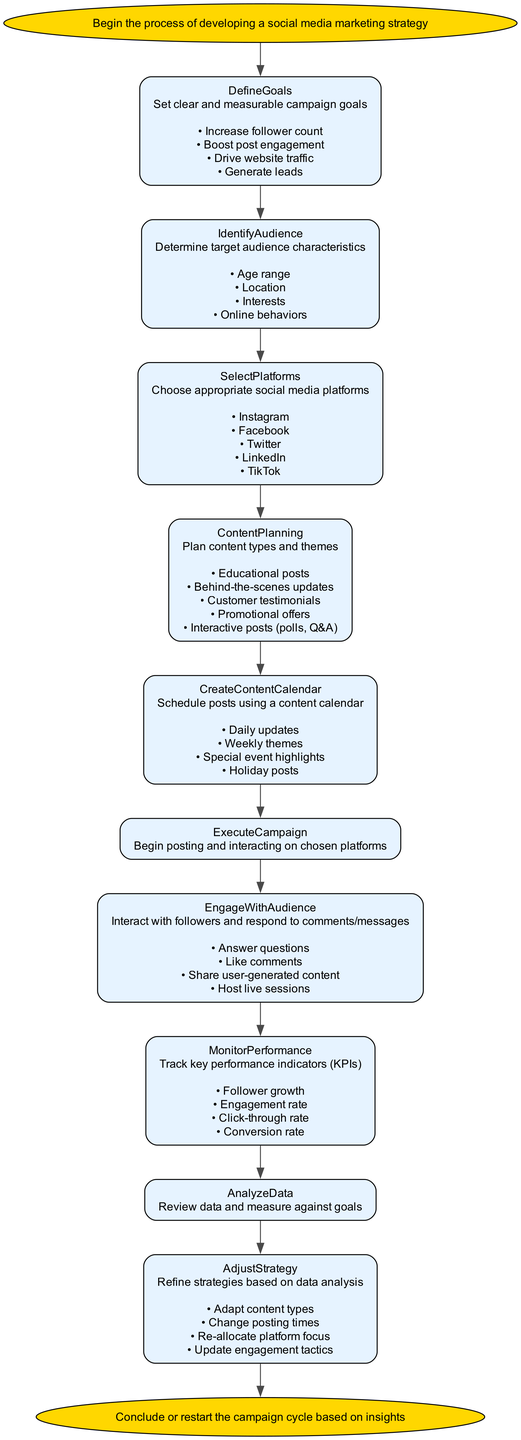What is the first step in the strategy development? The first step indicated in the flowchart is the "Start" node, which initiates the process of developing a social media marketing strategy.
Answer: Start How many subprocesses are listed under "Define Goals"? The "Define Goals" node has four subprocesses listed: Increase follower count, Boost post engagement, Drive website traffic, and Generate leads. Counting these subprocesses gives a total of four.
Answer: 4 What is the last node in the diagram? The final node in the flowchart is "End," which represents the conclusion or decision point of the campaign cycle.
Answer: End Which node follows "Select Platforms"? The node that follows "Select Platforms" in the flowchart is "Content Planning," indicating the transition from choosing platforms to planning content.
Answer: Content Planning What are the key performance indicators tracked in "Monitor Performance"? The "Monitor Performance" node outlines four key performance indicators to track: Follower growth, Engagement rate, Click-through rate, and Conversion rate.
Answer: Follower growth, Engagement rate, Click-through rate, Conversion rate Which node suggests interacting with followers? The node that suggests interacting with followers is "Engage With Audience," which emphasizes responding to comments and messages.
Answer: Engage With Audience How does one adjust the strategy after analyzing data? After analyzing data in the "Analyze Data" node, one can adjust the strategy in the "Adjust Strategy" node, which includes refining tactics based on insights.
Answer: Adjust Strategy What is one content type planned under "Content Planning"? One content type planned under the "Content Planning" node is "Educational posts," which aims to provide valuable information to the audience.
Answer: Educational posts What color is used for the "Start" and "End" nodes? Both the "Start" and "End" nodes are colored gold, emphasizing their significance as the beginning and end points of the process.
Answer: Gold 